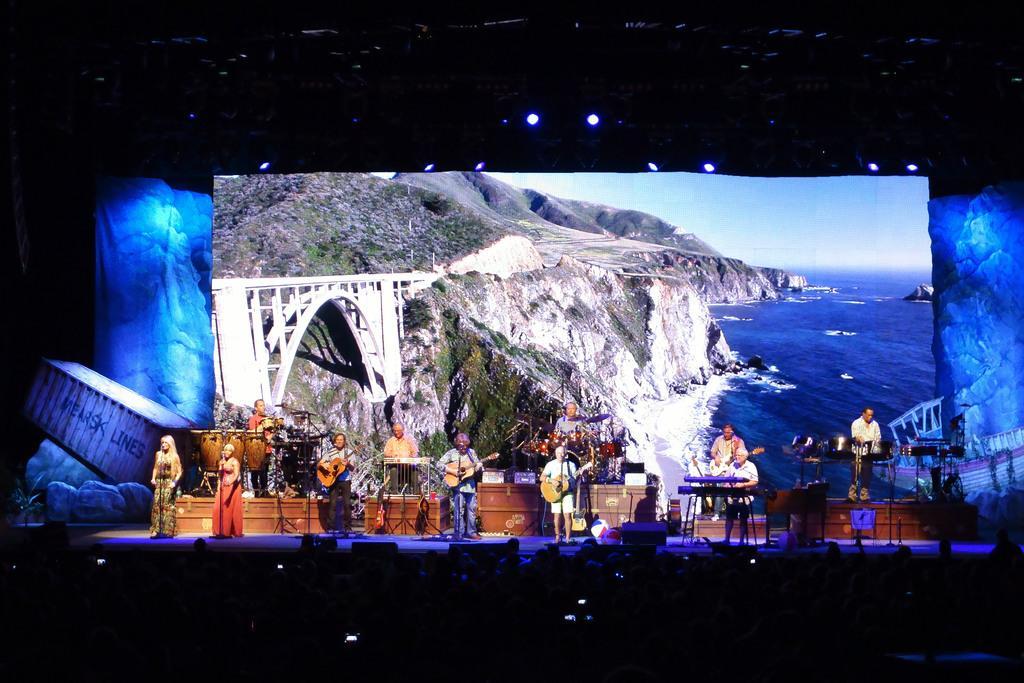Please provide a concise description of this image. In the image we can see there are people standing, wearing clothes and some of them are holding a musical instrument in their hands. Here we can see projected screen, in the projected screen we can see the water, arch, bridge, mountain and the sky. Here we can see the microphones on the stand. Here we can see the lights and the corners of the image are dark. 